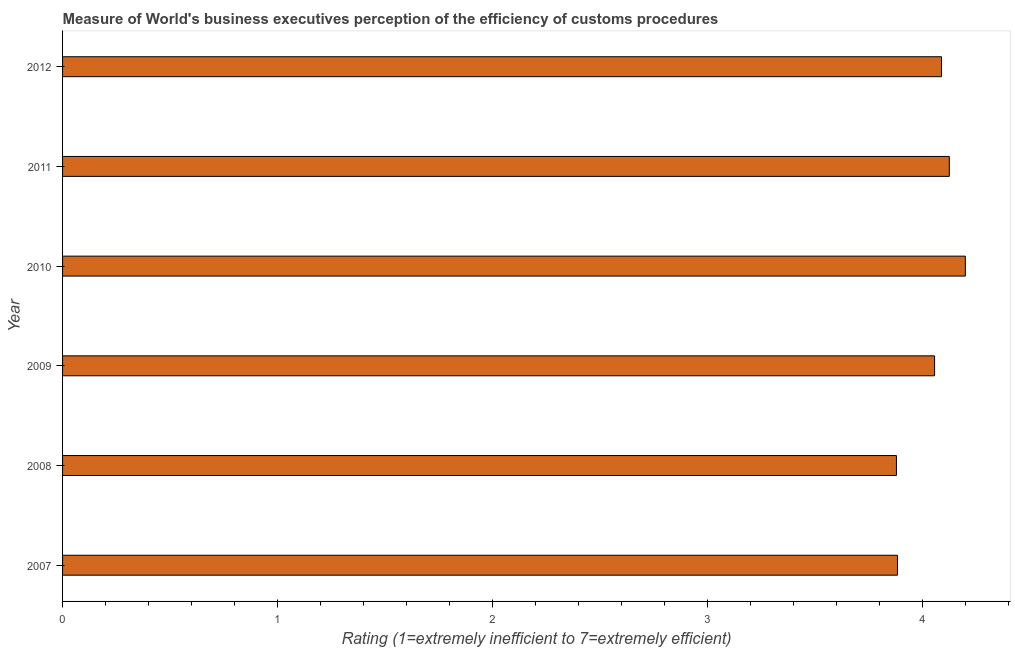Does the graph contain any zero values?
Keep it short and to the point. No. Does the graph contain grids?
Give a very brief answer. No. What is the title of the graph?
Your answer should be very brief. Measure of World's business executives perception of the efficiency of customs procedures. What is the label or title of the X-axis?
Make the answer very short. Rating (1=extremely inefficient to 7=extremely efficient). What is the label or title of the Y-axis?
Offer a very short reply. Year. What is the rating measuring burden of customs procedure in 2010?
Offer a very short reply. 4.2. Across all years, what is the maximum rating measuring burden of customs procedure?
Your response must be concise. 4.2. Across all years, what is the minimum rating measuring burden of customs procedure?
Your answer should be very brief. 3.88. In which year was the rating measuring burden of customs procedure minimum?
Your answer should be compact. 2008. What is the sum of the rating measuring burden of customs procedure?
Offer a very short reply. 24.23. What is the difference between the rating measuring burden of customs procedure in 2007 and 2010?
Provide a succinct answer. -0.32. What is the average rating measuring burden of customs procedure per year?
Your answer should be very brief. 4.04. What is the median rating measuring burden of customs procedure?
Give a very brief answer. 4.07. Is the difference between the rating measuring burden of customs procedure in 2007 and 2011 greater than the difference between any two years?
Provide a succinct answer. No. What is the difference between the highest and the second highest rating measuring burden of customs procedure?
Keep it short and to the point. 0.07. Is the sum of the rating measuring burden of customs procedure in 2007 and 2008 greater than the maximum rating measuring burden of customs procedure across all years?
Offer a very short reply. Yes. What is the difference between the highest and the lowest rating measuring burden of customs procedure?
Your answer should be very brief. 0.32. How many bars are there?
Keep it short and to the point. 6. Are all the bars in the graph horizontal?
Offer a very short reply. Yes. What is the difference between two consecutive major ticks on the X-axis?
Your answer should be very brief. 1. What is the Rating (1=extremely inefficient to 7=extremely efficient) of 2007?
Offer a terse response. 3.88. What is the Rating (1=extremely inefficient to 7=extremely efficient) in 2008?
Your answer should be compact. 3.88. What is the Rating (1=extremely inefficient to 7=extremely efficient) of 2009?
Make the answer very short. 4.06. What is the Rating (1=extremely inefficient to 7=extremely efficient) of 2010?
Provide a succinct answer. 4.2. What is the Rating (1=extremely inefficient to 7=extremely efficient) in 2011?
Offer a terse response. 4.12. What is the Rating (1=extremely inefficient to 7=extremely efficient) of 2012?
Provide a short and direct response. 4.09. What is the difference between the Rating (1=extremely inefficient to 7=extremely efficient) in 2007 and 2008?
Ensure brevity in your answer.  0. What is the difference between the Rating (1=extremely inefficient to 7=extremely efficient) in 2007 and 2009?
Give a very brief answer. -0.17. What is the difference between the Rating (1=extremely inefficient to 7=extremely efficient) in 2007 and 2010?
Provide a short and direct response. -0.32. What is the difference between the Rating (1=extremely inefficient to 7=extremely efficient) in 2007 and 2011?
Make the answer very short. -0.24. What is the difference between the Rating (1=extremely inefficient to 7=extremely efficient) in 2007 and 2012?
Provide a short and direct response. -0.2. What is the difference between the Rating (1=extremely inefficient to 7=extremely efficient) in 2008 and 2009?
Keep it short and to the point. -0.18. What is the difference between the Rating (1=extremely inefficient to 7=extremely efficient) in 2008 and 2010?
Your response must be concise. -0.32. What is the difference between the Rating (1=extremely inefficient to 7=extremely efficient) in 2008 and 2011?
Provide a short and direct response. -0.25. What is the difference between the Rating (1=extremely inefficient to 7=extremely efficient) in 2008 and 2012?
Provide a succinct answer. -0.21. What is the difference between the Rating (1=extremely inefficient to 7=extremely efficient) in 2009 and 2010?
Ensure brevity in your answer.  -0.14. What is the difference between the Rating (1=extremely inefficient to 7=extremely efficient) in 2009 and 2011?
Give a very brief answer. -0.07. What is the difference between the Rating (1=extremely inefficient to 7=extremely efficient) in 2009 and 2012?
Your answer should be very brief. -0.03. What is the difference between the Rating (1=extremely inefficient to 7=extremely efficient) in 2010 and 2011?
Keep it short and to the point. 0.07. What is the difference between the Rating (1=extremely inefficient to 7=extremely efficient) in 2010 and 2012?
Your response must be concise. 0.11. What is the difference between the Rating (1=extremely inefficient to 7=extremely efficient) in 2011 and 2012?
Your answer should be very brief. 0.04. What is the ratio of the Rating (1=extremely inefficient to 7=extremely efficient) in 2007 to that in 2008?
Provide a succinct answer. 1. What is the ratio of the Rating (1=extremely inefficient to 7=extremely efficient) in 2007 to that in 2009?
Offer a terse response. 0.96. What is the ratio of the Rating (1=extremely inefficient to 7=extremely efficient) in 2007 to that in 2010?
Provide a succinct answer. 0.93. What is the ratio of the Rating (1=extremely inefficient to 7=extremely efficient) in 2007 to that in 2011?
Your response must be concise. 0.94. What is the ratio of the Rating (1=extremely inefficient to 7=extremely efficient) in 2007 to that in 2012?
Give a very brief answer. 0.95. What is the ratio of the Rating (1=extremely inefficient to 7=extremely efficient) in 2008 to that in 2009?
Provide a short and direct response. 0.96. What is the ratio of the Rating (1=extremely inefficient to 7=extremely efficient) in 2008 to that in 2010?
Offer a terse response. 0.92. What is the ratio of the Rating (1=extremely inefficient to 7=extremely efficient) in 2008 to that in 2011?
Keep it short and to the point. 0.94. What is the ratio of the Rating (1=extremely inefficient to 7=extremely efficient) in 2008 to that in 2012?
Your answer should be compact. 0.95. What is the ratio of the Rating (1=extremely inefficient to 7=extremely efficient) in 2009 to that in 2010?
Offer a very short reply. 0.97. What is the ratio of the Rating (1=extremely inefficient to 7=extremely efficient) in 2010 to that in 2012?
Your answer should be compact. 1.03. What is the ratio of the Rating (1=extremely inefficient to 7=extremely efficient) in 2011 to that in 2012?
Give a very brief answer. 1.01. 